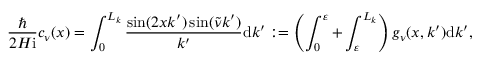Convert formula to latex. <formula><loc_0><loc_0><loc_500><loc_500>\frac { } { 2 H i } c _ { \nu } ( x ) = \int _ { 0 } ^ { L _ { k } } \frac { \sin ( 2 x k ^ { \prime } ) \sin ( \tilde { \nu } k ^ { \prime } ) } { k ^ { \prime } } d k ^ { \prime } \colon = \left ( \int _ { 0 } ^ { \varepsilon } + \int _ { \varepsilon } ^ { L _ { k } } \right ) g _ { \nu } ( x , k ^ { \prime } ) d k ^ { \prime } ,</formula> 